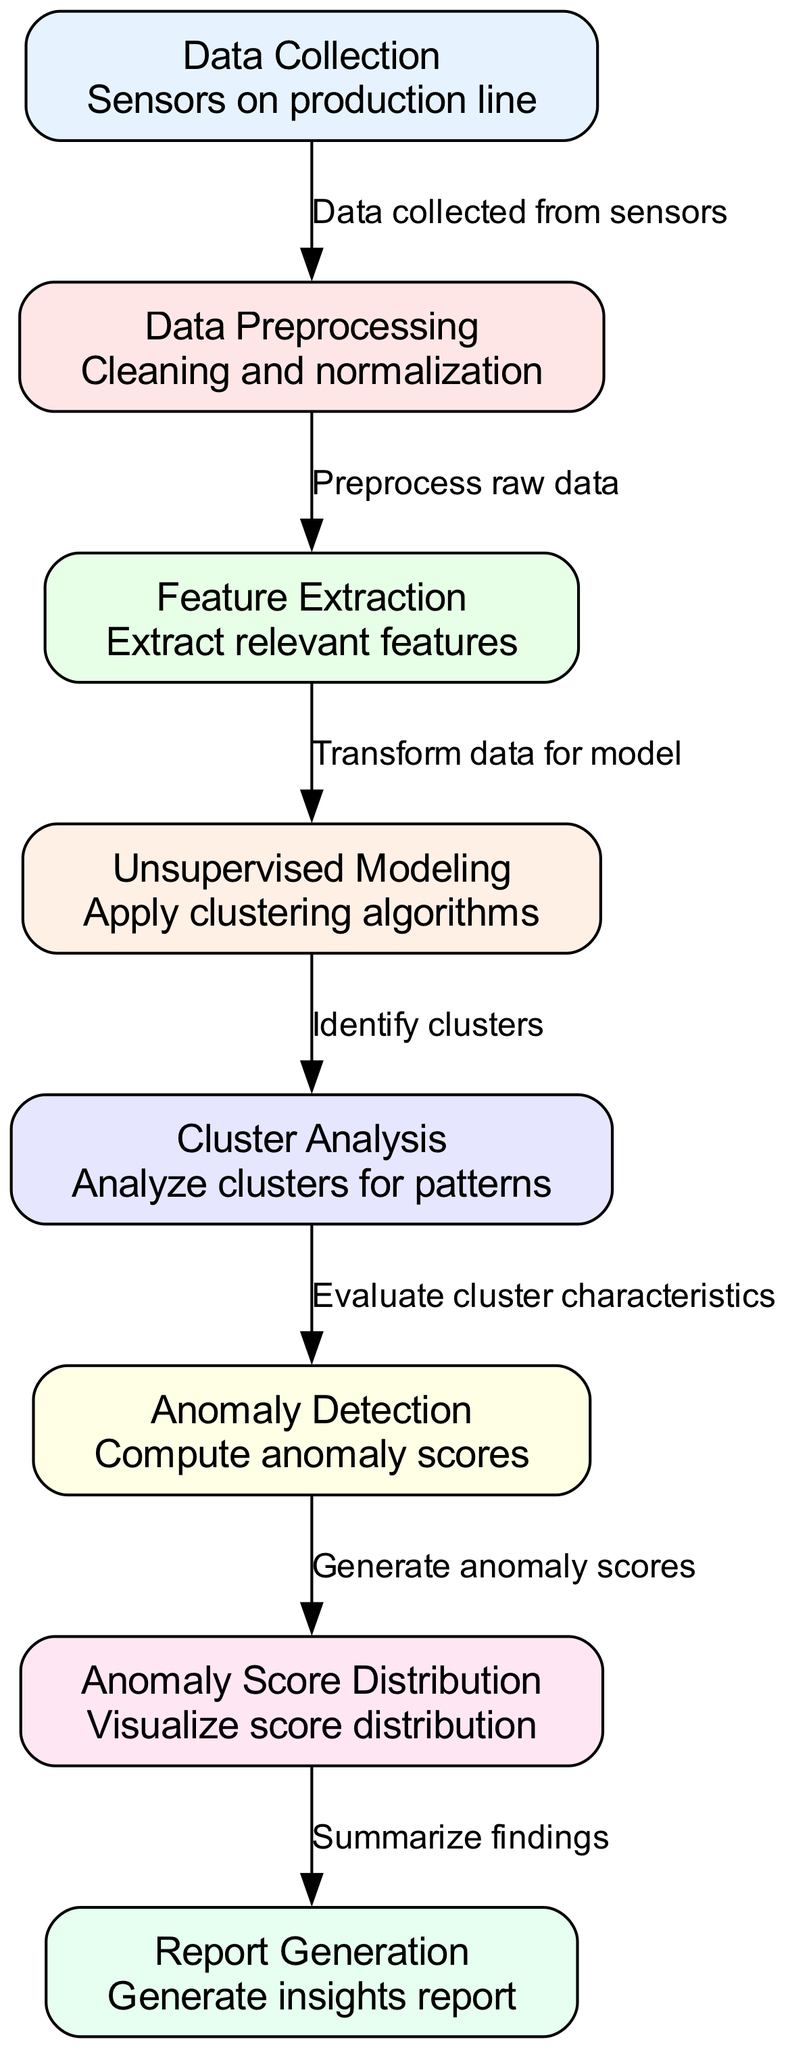What is the first step in the diagram? The diagram starts with the "Data Collection" node, which indicates that data is collected from sensors on the production line.
Answer: Data Collection How many nodes are present in the diagram? The diagram consists of seven nodes that represent different stages of the process, from data collection to report generation.
Answer: Seven What is the relationship between "Cluster Analysis" and "Anomaly Detection"? "Cluster Analysis" evaluates cluster characteristics and then sends the results to "Anomaly Detection." This indicates that the analysis of clusters informs the anomaly detection process.
Answer: Evaluate cluster characteristics Which node directly outputs the visualization of the score distribution? The node "Anomaly Score Distribution" is responsible for visualizing the distribution of the anomaly scores generated in the previous steps.
Answer: Anomaly Score Distribution How is data transformed before modeling? The "Feature Extraction" node transforms the preprocessed data into a form suitable for modeling by extracting relevant features.
Answer: Transform data for model What process follows after "Unsupervised Modeling"? After "Unsupervised Modeling," the next process is "Cluster Analysis," where identified clusters are analyzed for patterns.
Answer: Analyze clusters for patterns Explain how anomaly scores are generated in this diagram. Anomaly scores are generated in the "Anomaly Detection" node, which computes these scores based on the evaluations made in the preceding "Cluster Analysis" node. The flow begins with clustering, followed by this detection process.
Answer: Compute anomaly scores What is the final step in the diagram? The final step is "Report Generation," where the findings from the preceding analysis are summarized into an insights report.
Answer: Report Generation Which node is responsible for data preprocessing? The "Data Preprocessing" node is responsible for cleaning and normalizing the raw data collected from sensors.
Answer: Data Preprocessing 